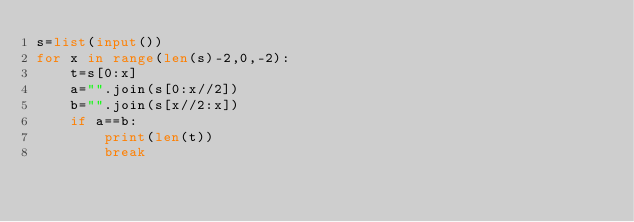<code> <loc_0><loc_0><loc_500><loc_500><_Python_>s=list(input())
for x in range(len(s)-2,0,-2):
    t=s[0:x]
    a="".join(s[0:x//2])
    b="".join(s[x//2:x])
    if a==b:
        print(len(t))
        break</code> 